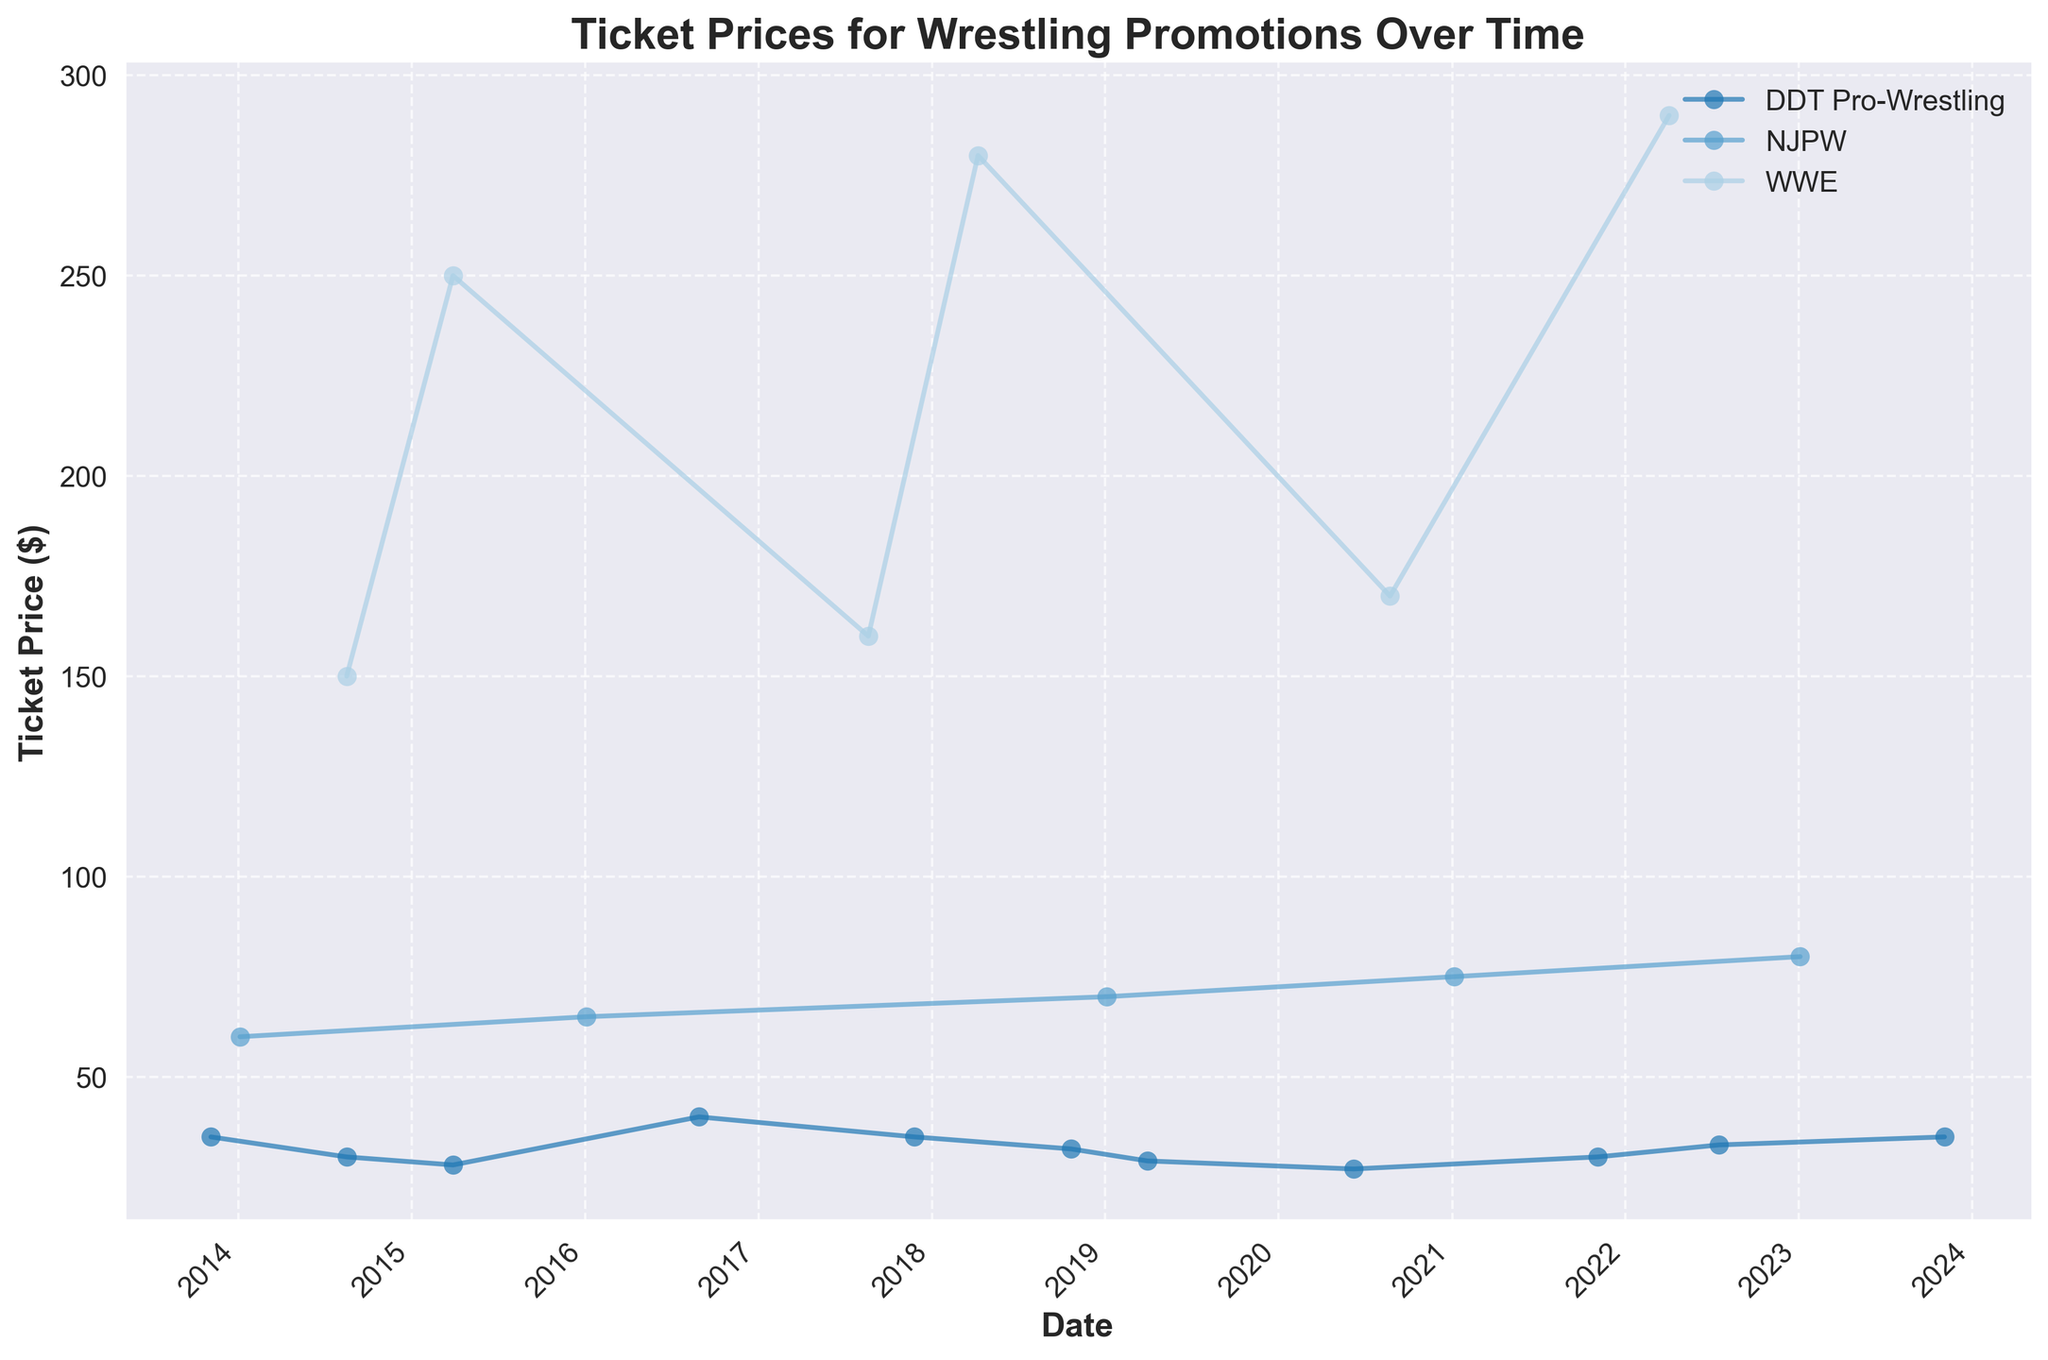what is the title of the plot? The plot's title is displayed at the top and is a larger and bolder text compared to other labels.
Answer: Ticket Prices for Wrestling Promotions Over Time Which promotion has the highest ticket price in 2022? Identify the data points for each promotion in the year 2022 and find the one with the highest value on the vertical axis (ticket price).
Answer: WWE How do DDT Pro-Wrestling's ticket prices trend from 2013 to 2023? Observe the line representing DDT Pro-Wrestling, tracing its movement from left (2013) to right (2023). Note any increases, decreases, or stable periods.
Answer: Generally stable with minor fluctuations Which promotion had the lowest attendance rate in 2020? Look for the data points corresponding to the year 2020 and compare the attendance rate values.
Answer: DDT Pro-Wrestling Compare the ticket price of WrestleMania 31 in 2015 to WrestleMania 38 in 2022. Locate the data points for WrestleMania in 2015 and 2022 and compare their values on the vertical axis (ticket price).
Answer: WrestleMania 38 is higher What is the average ticket price for DDT Pro-Wrestling events over the years? Sum up the ticket prices of all DDT Pro-Wrestling events and divide by the number of such events.
Answer: ($35+$30+$28+$40+$35+$32+$29+$27+$30+$33+$35)/11 = $32.09 Did WWE or NJPW experience a larger increase in ticket prices from 2014 to 2023? Subtract the 2014 ticket price from the 2023 ticket price for both promotions and compare the differences.
Answer: WWE How do ticket prices for NJPW events in 2016 compare to those in 2019? Identify the ticket prices for NJPW in 2016 and 2019 and compare their values on the vertical axis.
Answer: 2019 is higher What is the typical format for the horizontal axis labels? Observe the format of the dates displayed along the horizontal axis (X-axis).
Answer: Year format (YYYY) Which promotion consistently has higher ticket prices throughout the years? Compare the general trend lines of the promotions over the timeline and identify which one usually has higher values.
Answer: WWE 